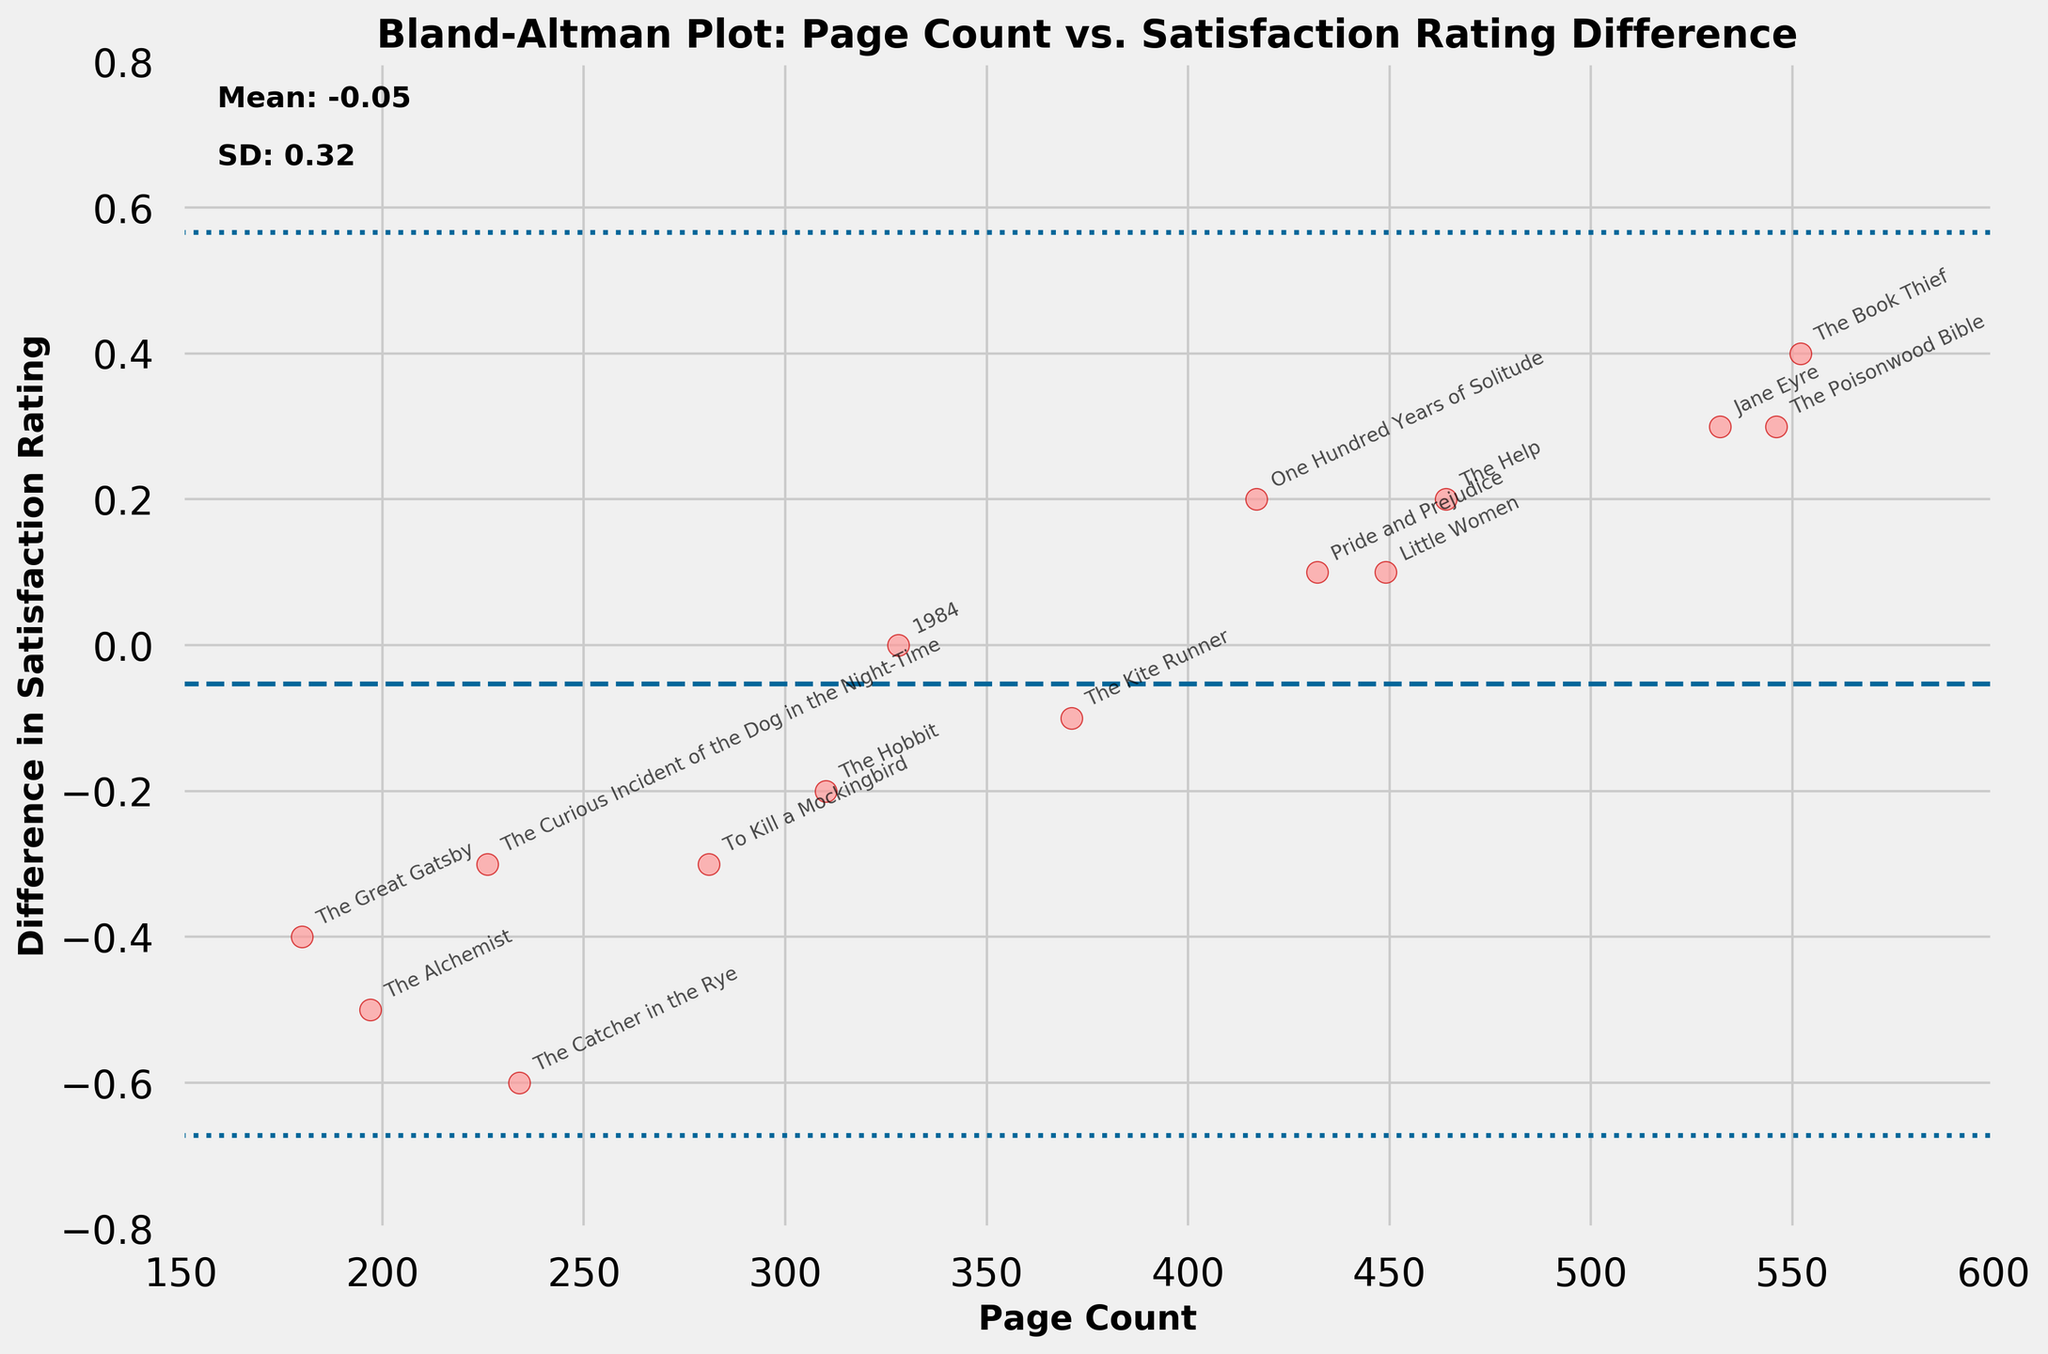What's the title of the plot? The title is located at the top of the figure, indicating what the plot represents.
Answer: Bland-Altman Plot: Page Count vs. Satisfaction Rating Difference What's the mean difference in satisfaction ratings? The mean difference is typically indicated by a horizontal line on the Bland-Altman plot, and you can often find this value annotated directly on the plot.
Answer: -0.08 What color are the data points? The data points are represented by a specific color in the scatter plot; observing the figure indicates their color.
Answer: Light red with darker red edges What's the highest satisfaction rating difference, and which book does it belong to? You can determine this by finding the data point with the highest value on the y-axis and reading the annotated label next to it.
Answer: 0.4, "The Book Thief" Which book has a page count closest to 300 pages, and what is its satisfaction rating difference? You need to identify the point closest to 300 on the x-axis and read the book title and its corresponding y-axis value.
Answer: "The Hobbit", -0.2 How many data points fall within the 95% confidence interval for the difference? Identify how many points lie between the two dashed lines representing the mean difference ± 1.96*SD. Count the points lying within these bounds.
Answer: 11 What's the range of page counts in the novels? The range can be determined by identifying the minimum and maximum values on the x-axis (page count).
Answer: 180 to 552 What's the difference between the highest and lowest satisfaction rating differences? Identify the maximum and minimum differences on the y-axis and calculate their difference.
Answer: 0.4 - (-0.6) = 1.0 Which book has the lowest rating difference, and how does it relate to the mean rating difference? Find the book with the minimum y-axis value and compare it to the plotted mean line.
Answer: "The Catcher in the Rye", and it is lower than the mean rating difference (-0.08) How many books have a satisfaction rating difference above zero? Identify and count the number of data points that are above the y-axis value of zero.
Answer: 5 